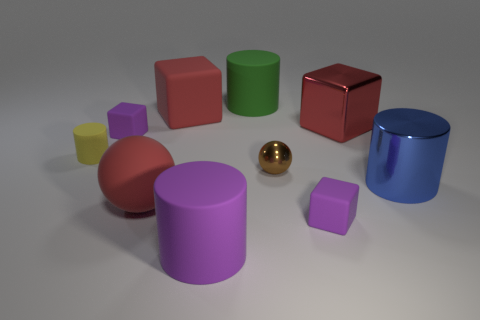There is a metallic cylinder; does it have the same size as the red matte thing that is behind the large red ball?
Provide a succinct answer. Yes. There is a large metal object behind the yellow cylinder; are there any small shiny spheres behind it?
Provide a succinct answer. No. There is a tiny purple matte object that is in front of the blue metal thing; what shape is it?
Provide a short and direct response. Cube. What material is the big ball that is the same color as the metal block?
Give a very brief answer. Rubber. What is the color of the large rubber thing in front of the tiny rubber cube that is on the right side of the green matte thing?
Give a very brief answer. Purple. Do the yellow rubber thing and the brown object have the same size?
Keep it short and to the point. Yes. There is a large blue thing that is the same shape as the tiny yellow thing; what is its material?
Keep it short and to the point. Metal. How many other metallic blocks are the same size as the red metal cube?
Keep it short and to the point. 0. What color is the cylinder that is made of the same material as the tiny brown sphere?
Keep it short and to the point. Blue. Are there fewer gray shiny objects than big blue metal cylinders?
Your response must be concise. Yes. 